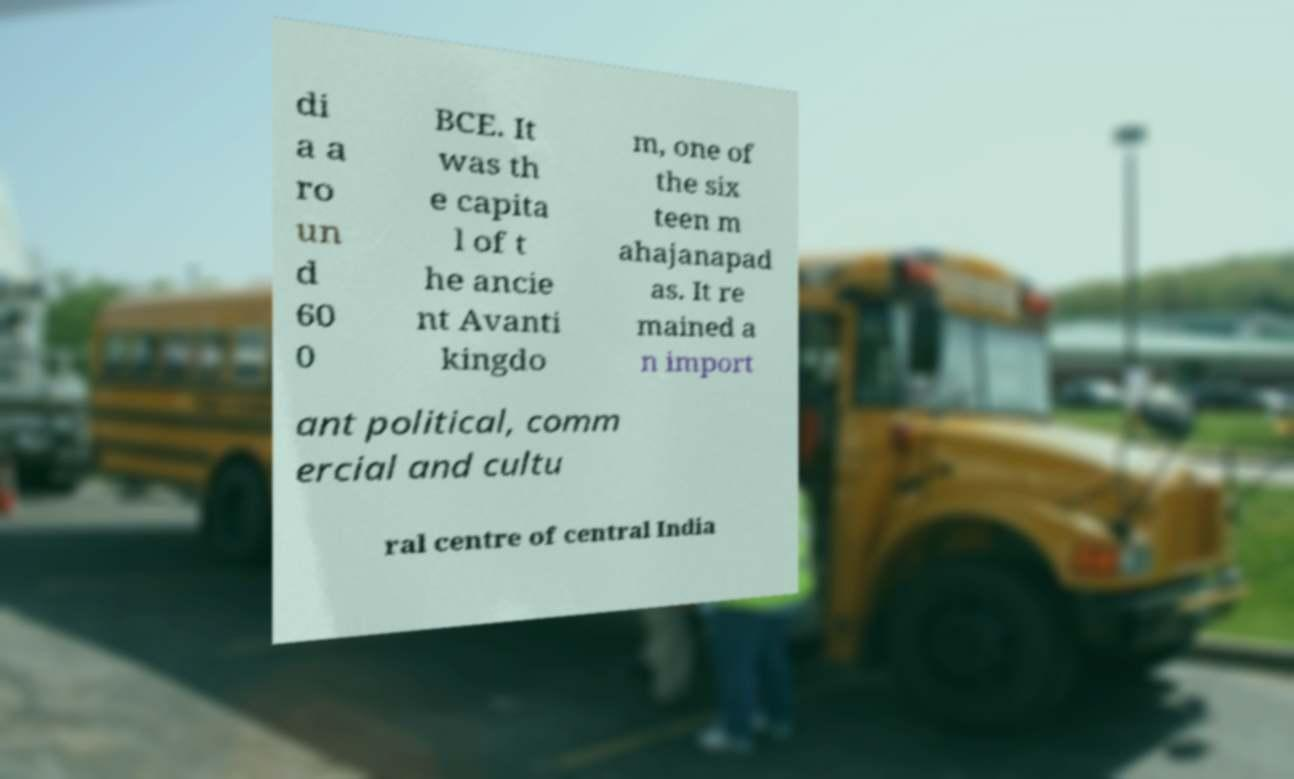Can you read and provide the text displayed in the image?This photo seems to have some interesting text. Can you extract and type it out for me? di a a ro un d 60 0 BCE. It was th e capita l of t he ancie nt Avanti kingdo m, one of the six teen m ahajanapad as. It re mained a n import ant political, comm ercial and cultu ral centre of central India 